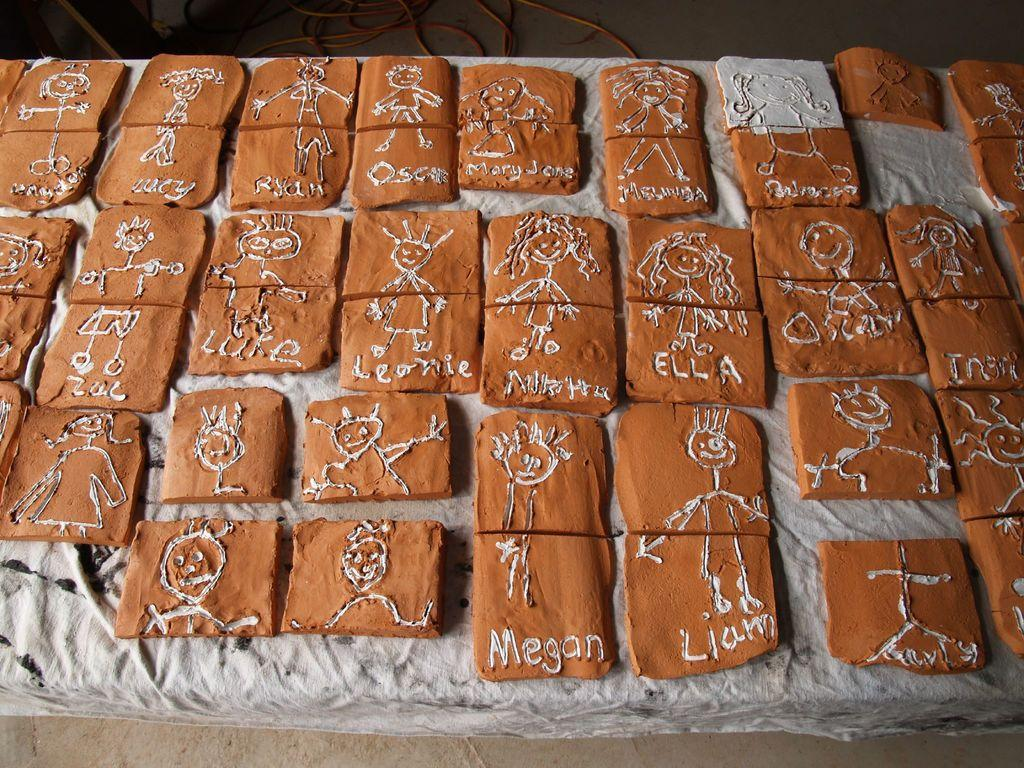What is the shape of the objects in the image? The objects in the image are square shaped. What material are the objects made of? The objects are made of clay. What can be seen on the surface of the objects? There are designs of persons on the objects. Are there any words or names on the objects? Yes, there are names on the objects. Where is the playground located in the image? There is no playground present in the image. What type of potato can be seen in the image? There is no potato present in the image. 